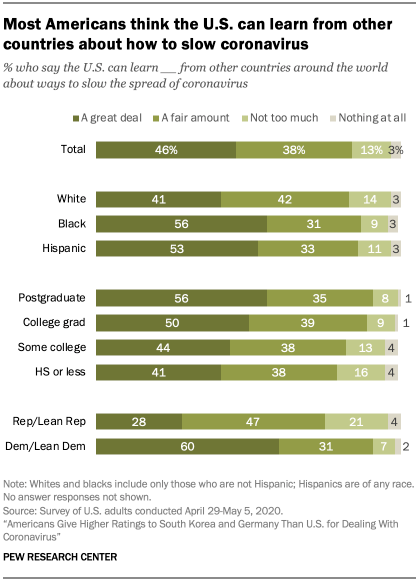Outline some significant characteristics in this image. There are how many gray bars with a value of 3? The color of the smallest bar in the Total category is gray. 